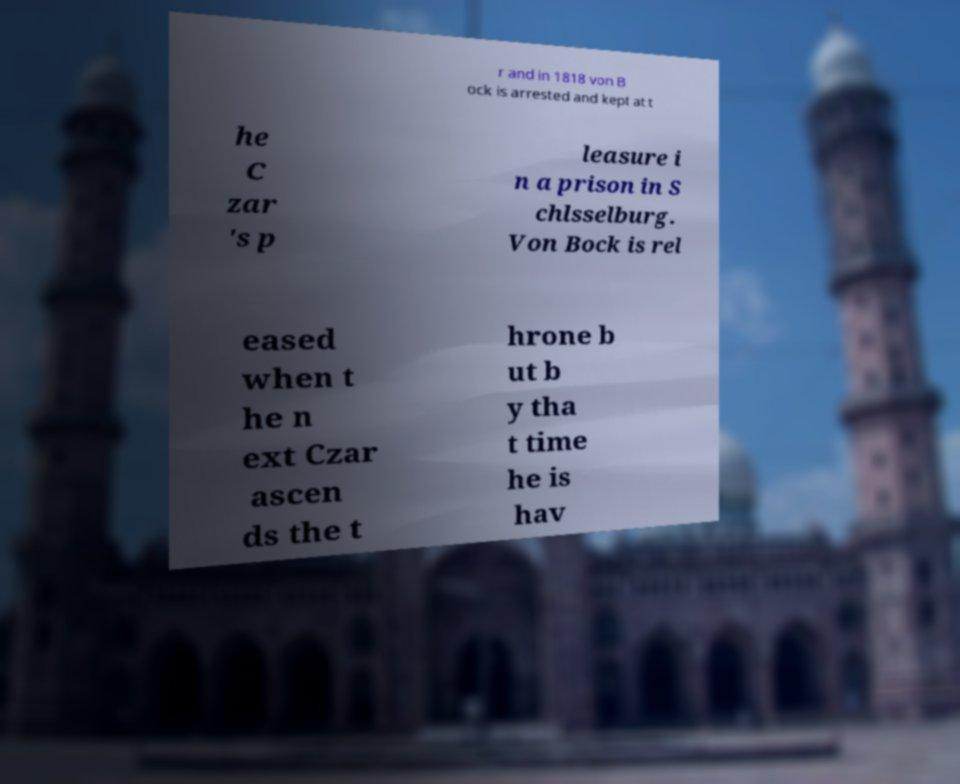Could you extract and type out the text from this image? r and in 1818 von B ock is arrested and kept at t he C zar 's p leasure i n a prison in S chlsselburg. Von Bock is rel eased when t he n ext Czar ascen ds the t hrone b ut b y tha t time he is hav 